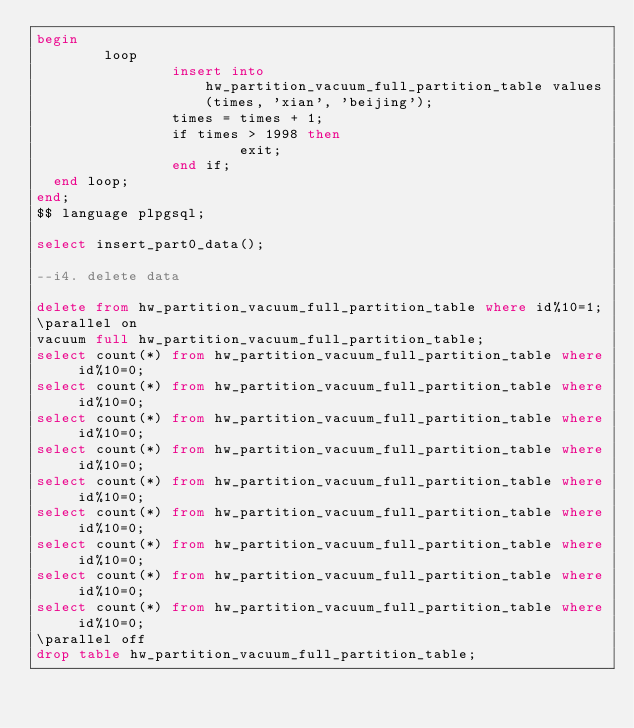<code> <loc_0><loc_0><loc_500><loc_500><_SQL_>begin
        loop
                insert into hw_partition_vacuum_full_partition_table values(times, 'xian', 'beijing');
                times = times + 1;
                if times > 1998 then
                        exit;
                end if;
  end loop;
end;
$$ language plpgsql;

select insert_part0_data();

--i4. delete data

delete from hw_partition_vacuum_full_partition_table where id%10=1;
\parallel on
vacuum full hw_partition_vacuum_full_partition_table;
select count(*) from hw_partition_vacuum_full_partition_table where id%10=0;
select count(*) from hw_partition_vacuum_full_partition_table where id%10=0;
select count(*) from hw_partition_vacuum_full_partition_table where id%10=0;
select count(*) from hw_partition_vacuum_full_partition_table where id%10=0;
select count(*) from hw_partition_vacuum_full_partition_table where id%10=0;
select count(*) from hw_partition_vacuum_full_partition_table where id%10=0;
select count(*) from hw_partition_vacuum_full_partition_table where id%10=0;
select count(*) from hw_partition_vacuum_full_partition_table where id%10=0;
select count(*) from hw_partition_vacuum_full_partition_table where id%10=0;
\parallel off
drop table hw_partition_vacuum_full_partition_table;
</code> 